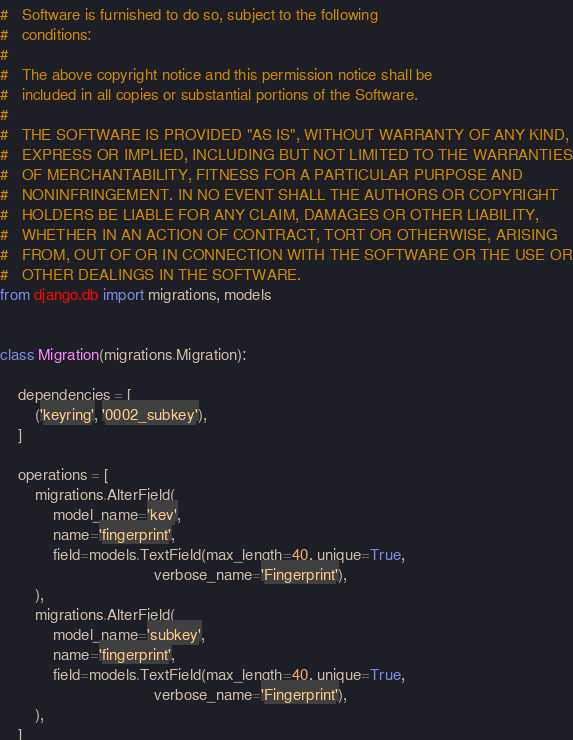<code> <loc_0><loc_0><loc_500><loc_500><_Python_>#   Software is furnished to do so, subject to the following
#   conditions:
#
#   The above copyright notice and this permission notice shall be
#   included in all copies or substantial portions of the Software.
#
#   THE SOFTWARE IS PROVIDED "AS IS", WITHOUT WARRANTY OF ANY KIND,
#   EXPRESS OR IMPLIED, INCLUDING BUT NOT LIMITED TO THE WARRANTIES
#   OF MERCHANTABILITY, FITNESS FOR A PARTICULAR PURPOSE AND
#   NONINFRINGEMENT. IN NO EVENT SHALL THE AUTHORS OR COPYRIGHT
#   HOLDERS BE LIABLE FOR ANY CLAIM, DAMAGES OR OTHER LIABILITY,
#   WHETHER IN AN ACTION OF CONTRACT, TORT OR OTHERWISE, ARISING
#   FROM, OUT OF OR IN CONNECTION WITH THE SOFTWARE OR THE USE OR
#   OTHER DEALINGS IN THE SOFTWARE.
from django.db import migrations, models


class Migration(migrations.Migration):

    dependencies = [
        ('keyring', '0002_subkey'),
    ]

    operations = [
        migrations.AlterField(
            model_name='key',
            name='fingerprint',
            field=models.TextField(max_length=40, unique=True,
                                   verbose_name='Fingerprint'),
        ),
        migrations.AlterField(
            model_name='subkey',
            name='fingerprint',
            field=models.TextField(max_length=40, unique=True,
                                   verbose_name='Fingerprint'),
        ),
    ]
</code> 